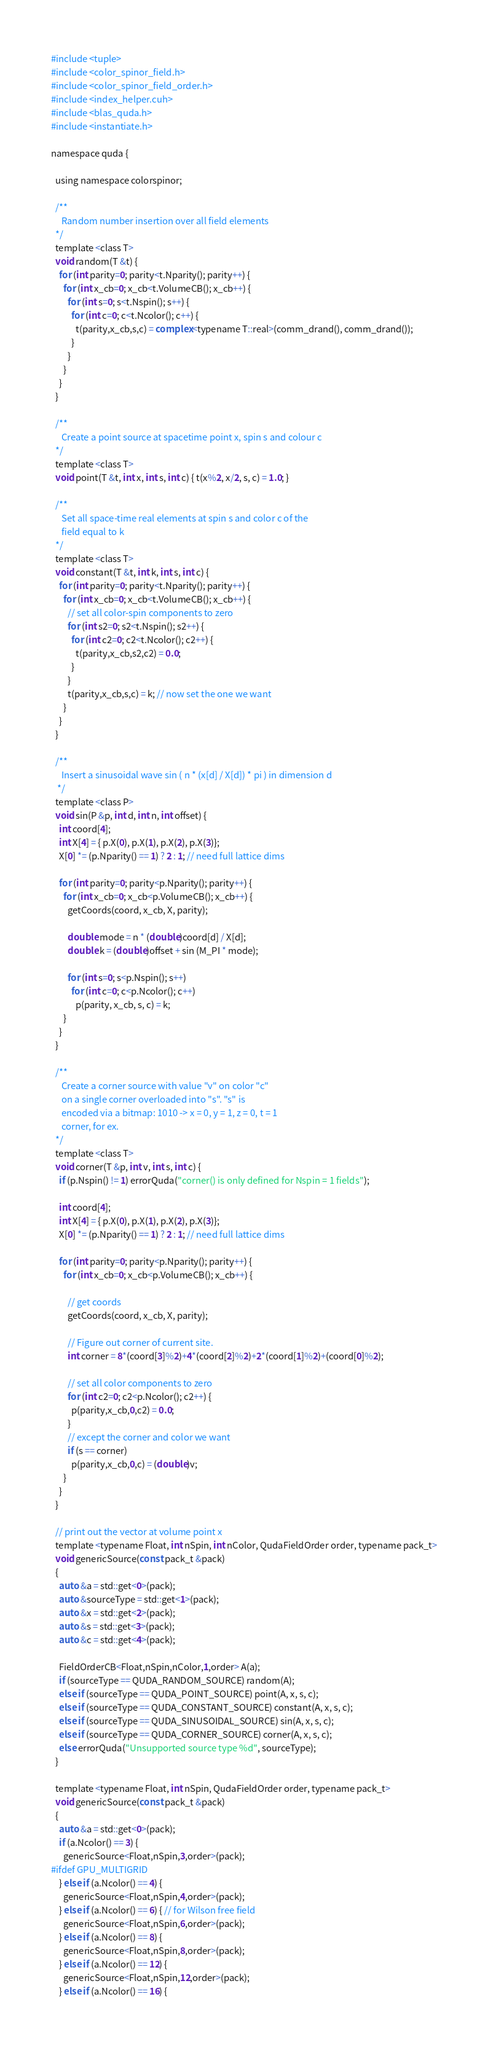Convert code to text. <code><loc_0><loc_0><loc_500><loc_500><_Cuda_>#include <tuple>
#include <color_spinor_field.h>
#include <color_spinor_field_order.h>
#include <index_helper.cuh>
#include <blas_quda.h>
#include <instantiate.h>

namespace quda {

  using namespace colorspinor;

  /**
     Random number insertion over all field elements
  */
  template <class T>
  void random(T &t) {
    for (int parity=0; parity<t.Nparity(); parity++) {
      for (int x_cb=0; x_cb<t.VolumeCB(); x_cb++) {
      	for (int s=0; s<t.Nspin(); s++) {
      	  for (int c=0; c<t.Ncolor(); c++) {
            t(parity,x_cb,s,c) = complex<typename T::real>(comm_drand(), comm_drand());
      	  }
      	}
      }
    }
  }

  /**
     Create a point source at spacetime point x, spin s and colour c
  */
  template <class T>
  void point(T &t, int x, int s, int c) { t(x%2, x/2, s, c) = 1.0; }

  /**
     Set all space-time real elements at spin s and color c of the
     field equal to k
  */
  template <class T>
  void constant(T &t, int k, int s, int c) {
    for (int parity=0; parity<t.Nparity(); parity++) {
      for (int x_cb=0; x_cb<t.VolumeCB(); x_cb++) {
      	// set all color-spin components to zero
      	for (int s2=0; s2<t.Nspin(); s2++) {
      	  for (int c2=0; c2<t.Ncolor(); c2++) {
      	    t(parity,x_cb,s2,c2) = 0.0;
      	  }
      	}
        t(parity,x_cb,s,c) = k; // now set the one we want
      }
    }
  }

  /**
     Insert a sinusoidal wave sin ( n * (x[d] / X[d]) * pi ) in dimension d
   */
  template <class P>
  void sin(P &p, int d, int n, int offset) {
    int coord[4];
    int X[4] = { p.X(0), p.X(1), p.X(2), p.X(3)};
    X[0] *= (p.Nparity() == 1) ? 2 : 1; // need full lattice dims

    for (int parity=0; parity<p.Nparity(); parity++) {
      for (int x_cb=0; x_cb<p.VolumeCB(); x_cb++) {
        getCoords(coord, x_cb, X, parity);

        double mode = n * (double)coord[d] / X[d];
        double k = (double)offset + sin (M_PI * mode);

        for (int s=0; s<p.Nspin(); s++)
          for (int c=0; c<p.Ncolor(); c++)
            p(parity, x_cb, s, c) = k;
      }
    }
  }

  /**
     Create a corner source with value "v" on color "c"
     on a single corner overloaded into "s". "s" is
     encoded via a bitmap: 1010 -> x = 0, y = 1, z = 0, t = 1
     corner, for ex.
  */
  template <class T>
  void corner(T &p, int v, int s, int c) {
    if (p.Nspin() != 1) errorQuda("corner() is only defined for Nspin = 1 fields");

    int coord[4];
    int X[4] = { p.X(0), p.X(1), p.X(2), p.X(3)};
    X[0] *= (p.Nparity() == 1) ? 2 : 1; // need full lattice dims

    for (int parity=0; parity<p.Nparity(); parity++) {
      for (int x_cb=0; x_cb<p.VolumeCB(); x_cb++) {

        // get coords
        getCoords(coord, x_cb, X, parity);

        // Figure out corner of current site.
        int corner = 8*(coord[3]%2)+4*(coord[2]%2)+2*(coord[1]%2)+(coord[0]%2);

        // set all color components to zero
        for (int c2=0; c2<p.Ncolor(); c2++) {
          p(parity,x_cb,0,c2) = 0.0;
        }
        // except the corner and color we want
        if (s == corner)
          p(parity,x_cb,0,c) = (double)v;
      }
    }
  }

  // print out the vector at volume point x
  template <typename Float, int nSpin, int nColor, QudaFieldOrder order, typename pack_t>
  void genericSource(const pack_t &pack)
  {
    auto &a = std::get<0>(pack);
    auto &sourceType = std::get<1>(pack);
    auto &x = std::get<2>(pack);
    auto &s = std::get<3>(pack);
    auto &c = std::get<4>(pack);

    FieldOrderCB<Float,nSpin,nColor,1,order> A(a);
    if (sourceType == QUDA_RANDOM_SOURCE) random(A);
    else if (sourceType == QUDA_POINT_SOURCE) point(A, x, s, c);
    else if (sourceType == QUDA_CONSTANT_SOURCE) constant(A, x, s, c);
    else if (sourceType == QUDA_SINUSOIDAL_SOURCE) sin(A, x, s, c);
    else if (sourceType == QUDA_CORNER_SOURCE) corner(A, x, s, c);
    else errorQuda("Unsupported source type %d", sourceType);
  }

  template <typename Float, int nSpin, QudaFieldOrder order, typename pack_t>
  void genericSource(const pack_t &pack)
  {
    auto &a = std::get<0>(pack);
    if (a.Ncolor() == 3) {
      genericSource<Float,nSpin,3,order>(pack);
#ifdef GPU_MULTIGRID
    } else if (a.Ncolor() == 4) {
      genericSource<Float,nSpin,4,order>(pack);
    } else if (a.Ncolor() == 6) { // for Wilson free field
      genericSource<Float,nSpin,6,order>(pack);
    } else if (a.Ncolor() == 8) {
      genericSource<Float,nSpin,8,order>(pack);
    } else if (a.Ncolor() == 12) {
      genericSource<Float,nSpin,12,order>(pack);
    } else if (a.Ncolor() == 16) {</code> 